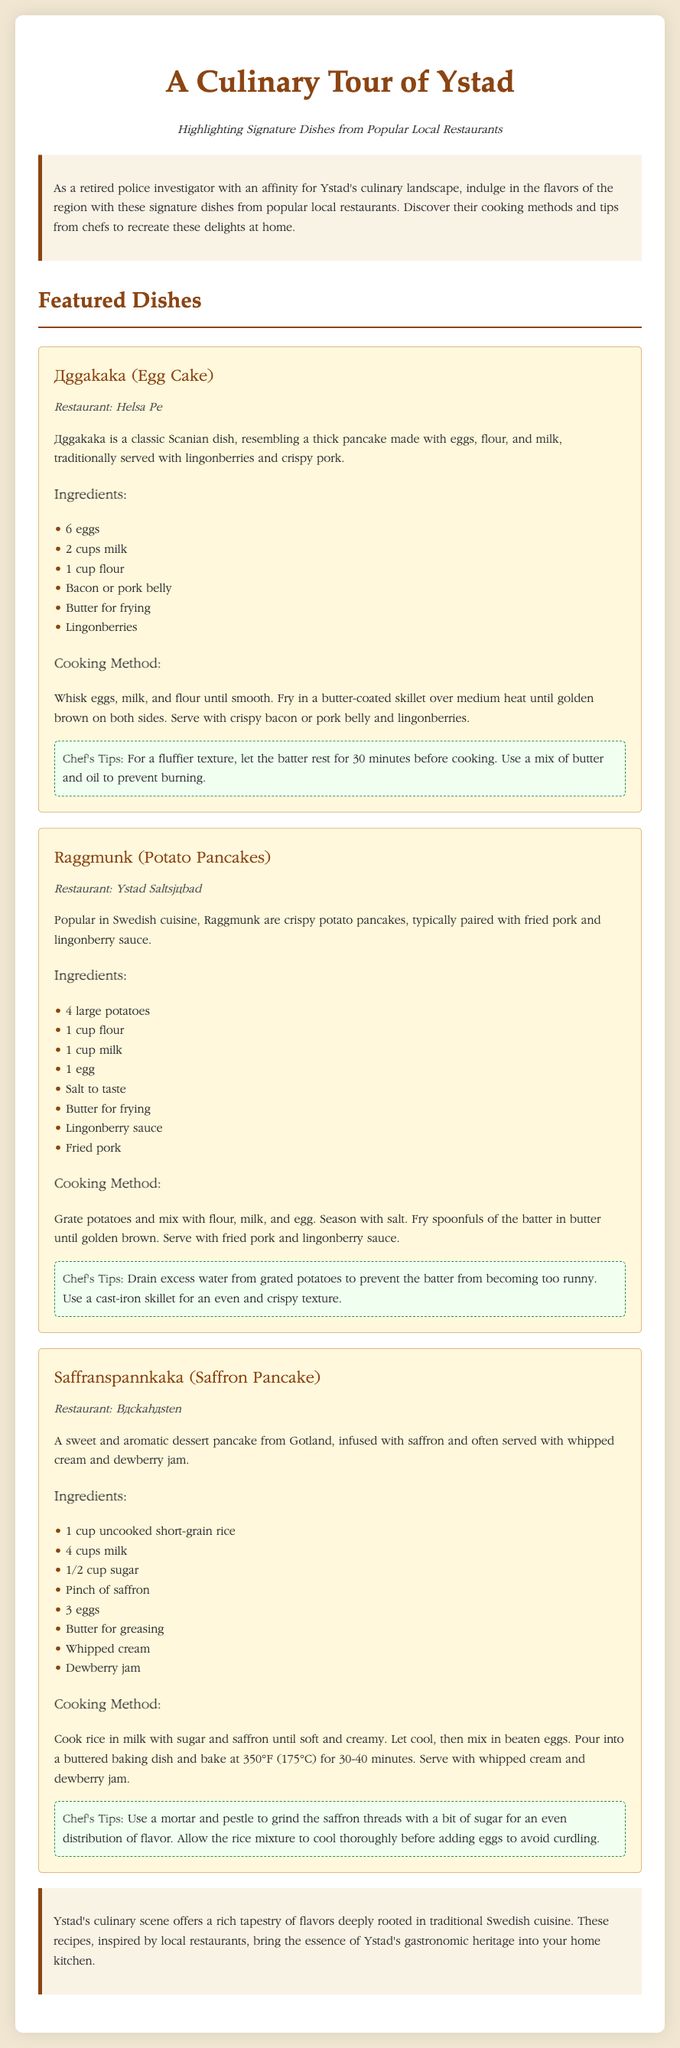What is the title of the document? The title of the document is stated in the <title> tag of the HTML, which describes the content of the document as a culinary tour.
Answer: A Culinary Tour of Ystad Which dish is served at Restaurant Helsa På? The dish associated with the restaurant is listed alongside its name and description under the Featured Dishes section.
Answer: Äggakaka (Egg Cake) How many eggs are needed for Äggakaka? The number of eggs is clearly listed in the ingredients section for Äggakaka.
Answer: 6 eggs What cooking method is used for Saffranspannkaka? The cooking method for Saffranspannkaka is explained in the cooking method section of the dish.
Answer: Bake What is one of the chef's tips for Raggmunk? Chef's tips are provided in a highlighted section for each dish, detailing specific cooking advice.
Answer: Drain excess water from grated potatoes Which restaurant serves Raggmunk? The restaurant name is mentioned directly under the dish name for Raggmunk in the document.
Answer: Ystad Saltsjöbad What is served with Saffranspannkaka? The accompaniments are mentioned in the description of Saffranspannkaka, indicating how it is traditionally served.
Answer: Whipped cream and dewberry jam What type of cuisine does Äggakaka belong to? The cuisine type is mentioned in the description of Äggakaka under the Featured Dishes section.
Answer: Scanian cuisine How long should the rice cool before adding eggs in Saffranspannkaka? The specific cooling time is given in the chef's tips for Saffranspannkaka.
Answer: Thoroughly 